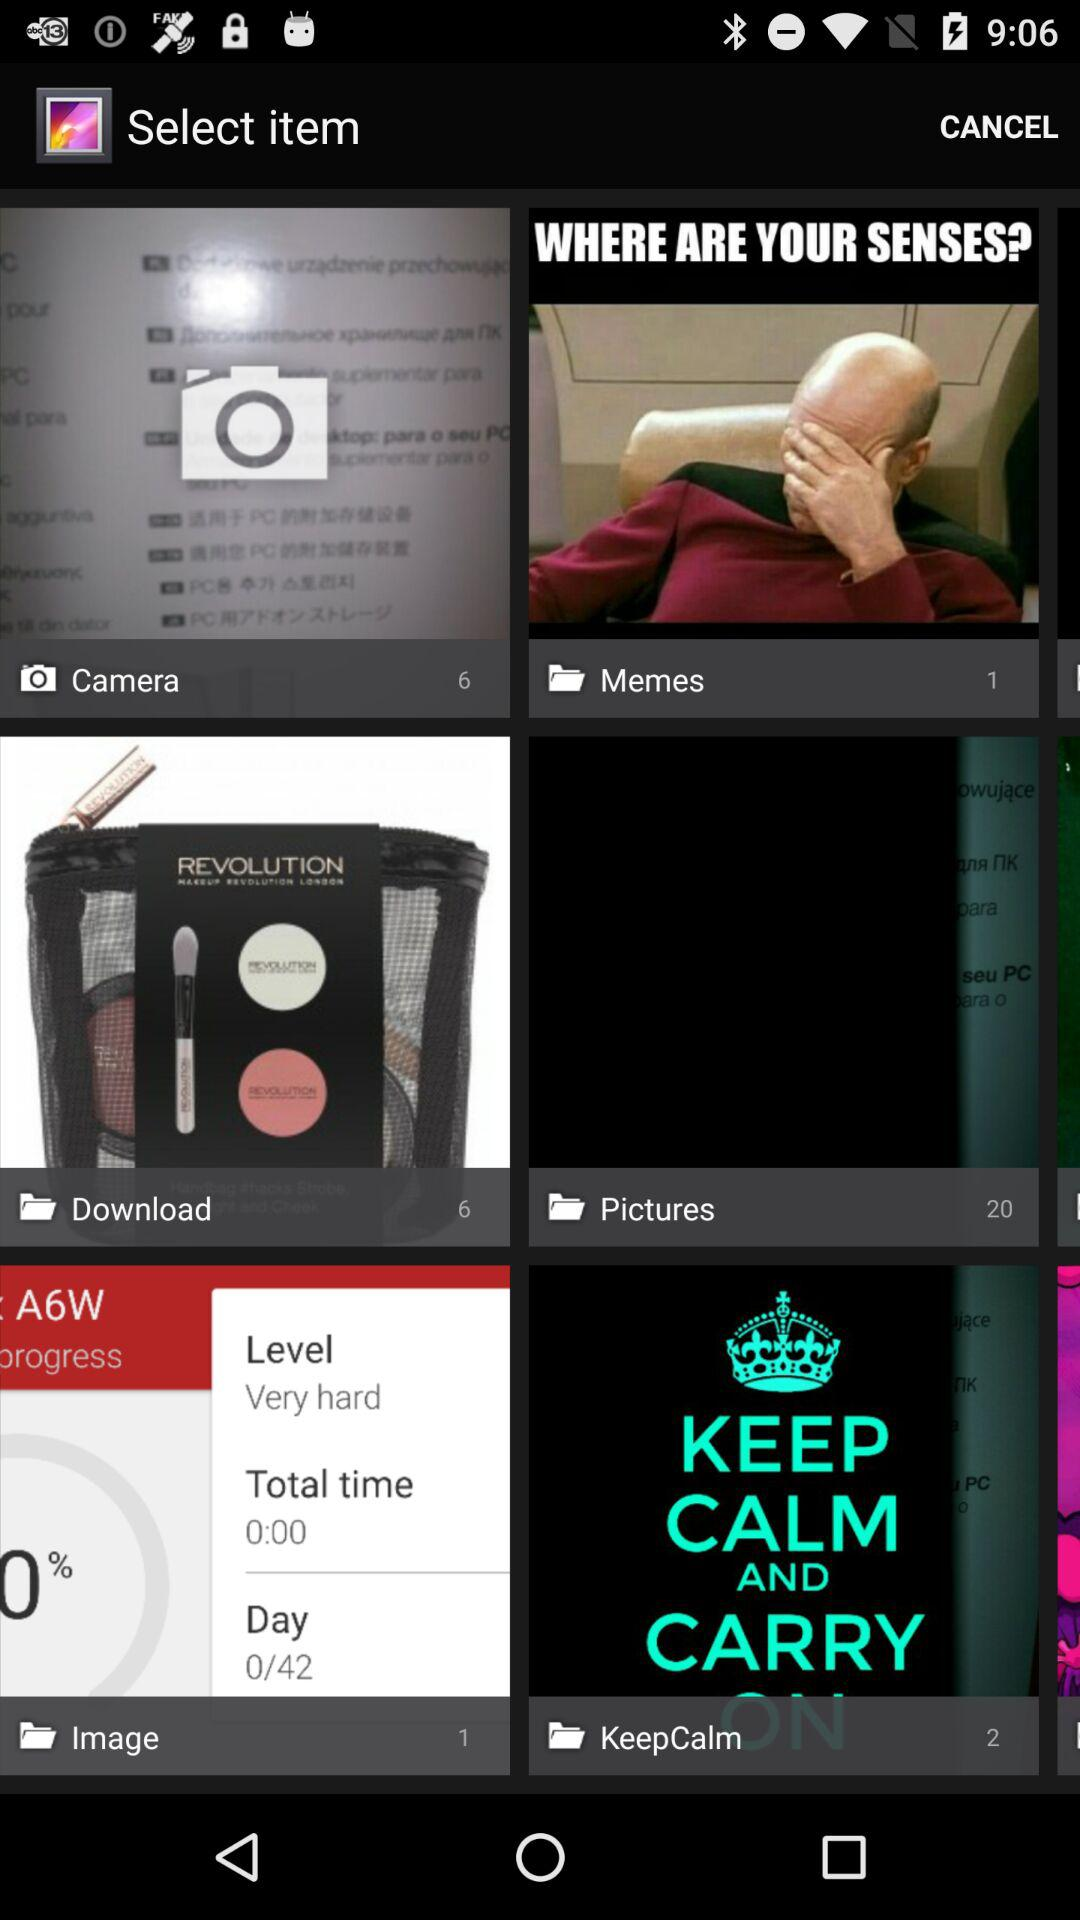How many photos are in "Download"? There are 6 photos in "Download". 